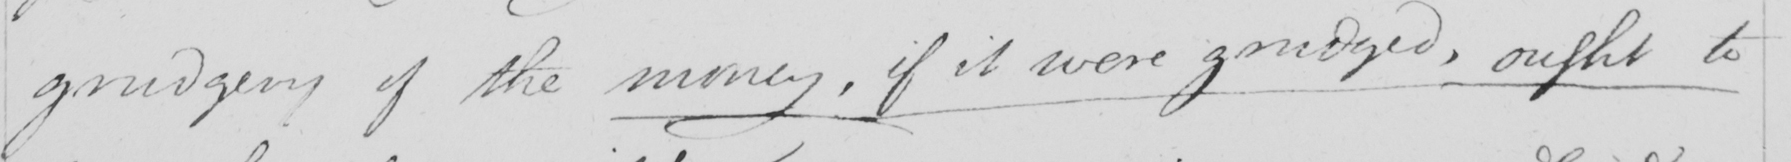Transcribe the text shown in this historical manuscript line. grudgery of the money , if it were grudged , ought to 